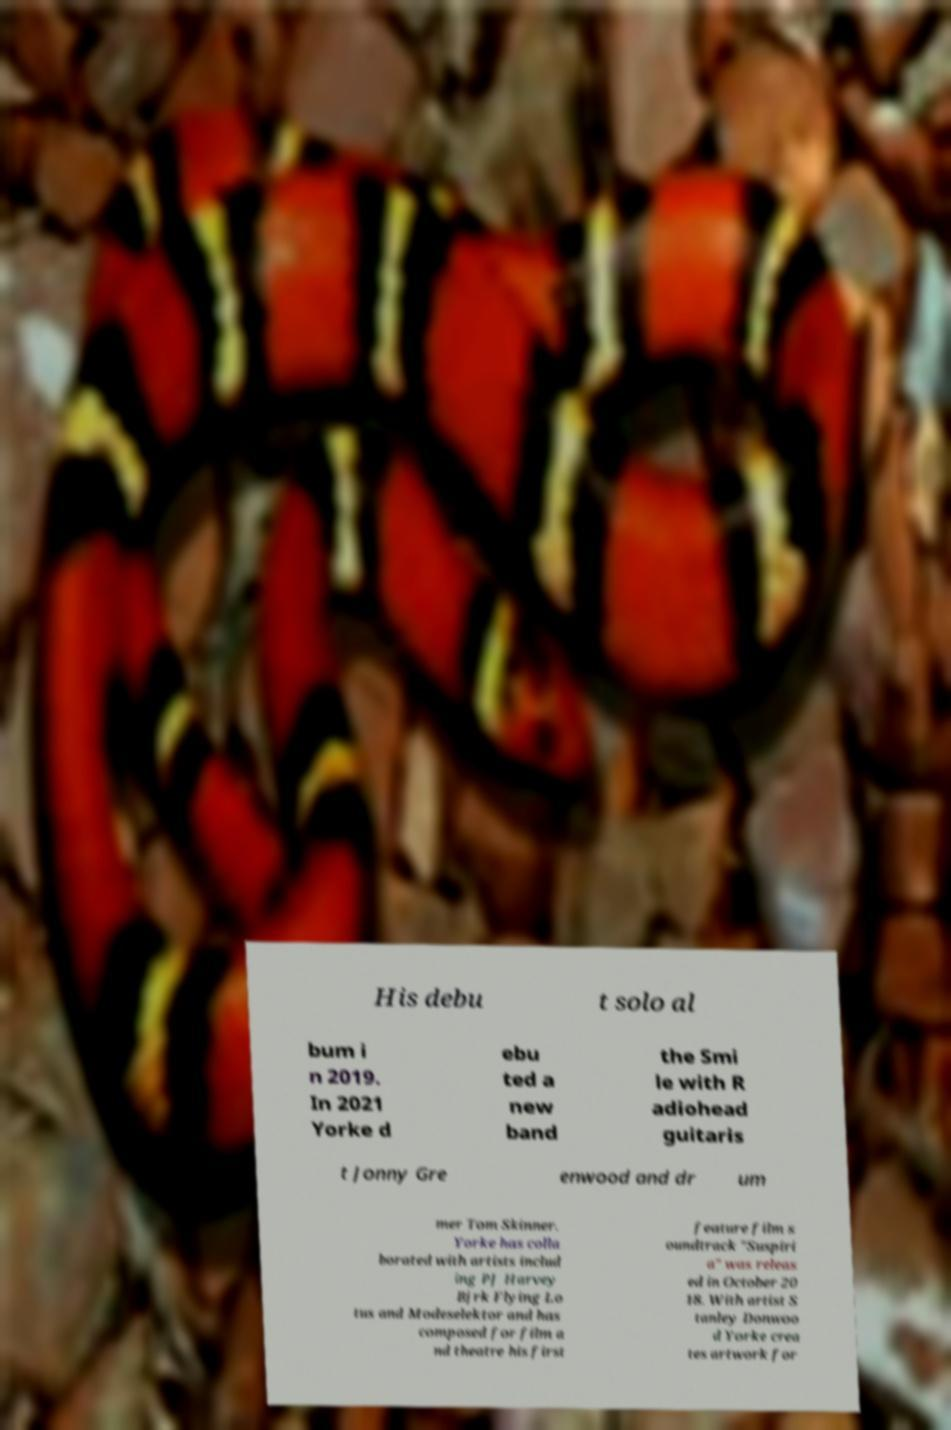I need the written content from this picture converted into text. Can you do that? His debu t solo al bum i n 2019. In 2021 Yorke d ebu ted a new band the Smi le with R adiohead guitaris t Jonny Gre enwood and dr um mer Tom Skinner. Yorke has colla borated with artists includ ing PJ Harvey Bjrk Flying Lo tus and Modeselektor and has composed for film a nd theatre his first feature film s oundtrack "Suspiri a" was releas ed in October 20 18. With artist S tanley Donwoo d Yorke crea tes artwork for 